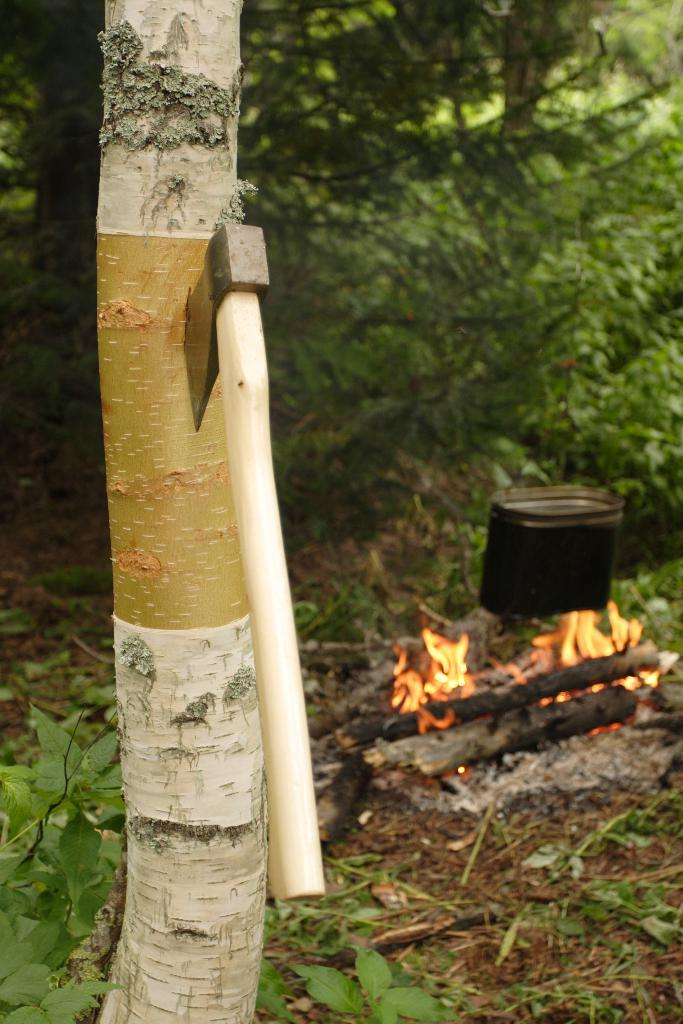What object is in the image that is typically used for storing items? There is a trunk in the image. What tool is placed on the trunk? There is an axe on the trunk. What can be seen in the background of the image? There is a fire and trees in the background of the image. What is the color of the trees in the background? The trees in the background are green in color. What type of yarn is the daughter using to sleep in the image? There is no daughter or yarn present in the image. How does the axe help the daughter sleep in the image? There is no daughter or sleeping mentioned in the image; the axe is simply placed on the trunk. 